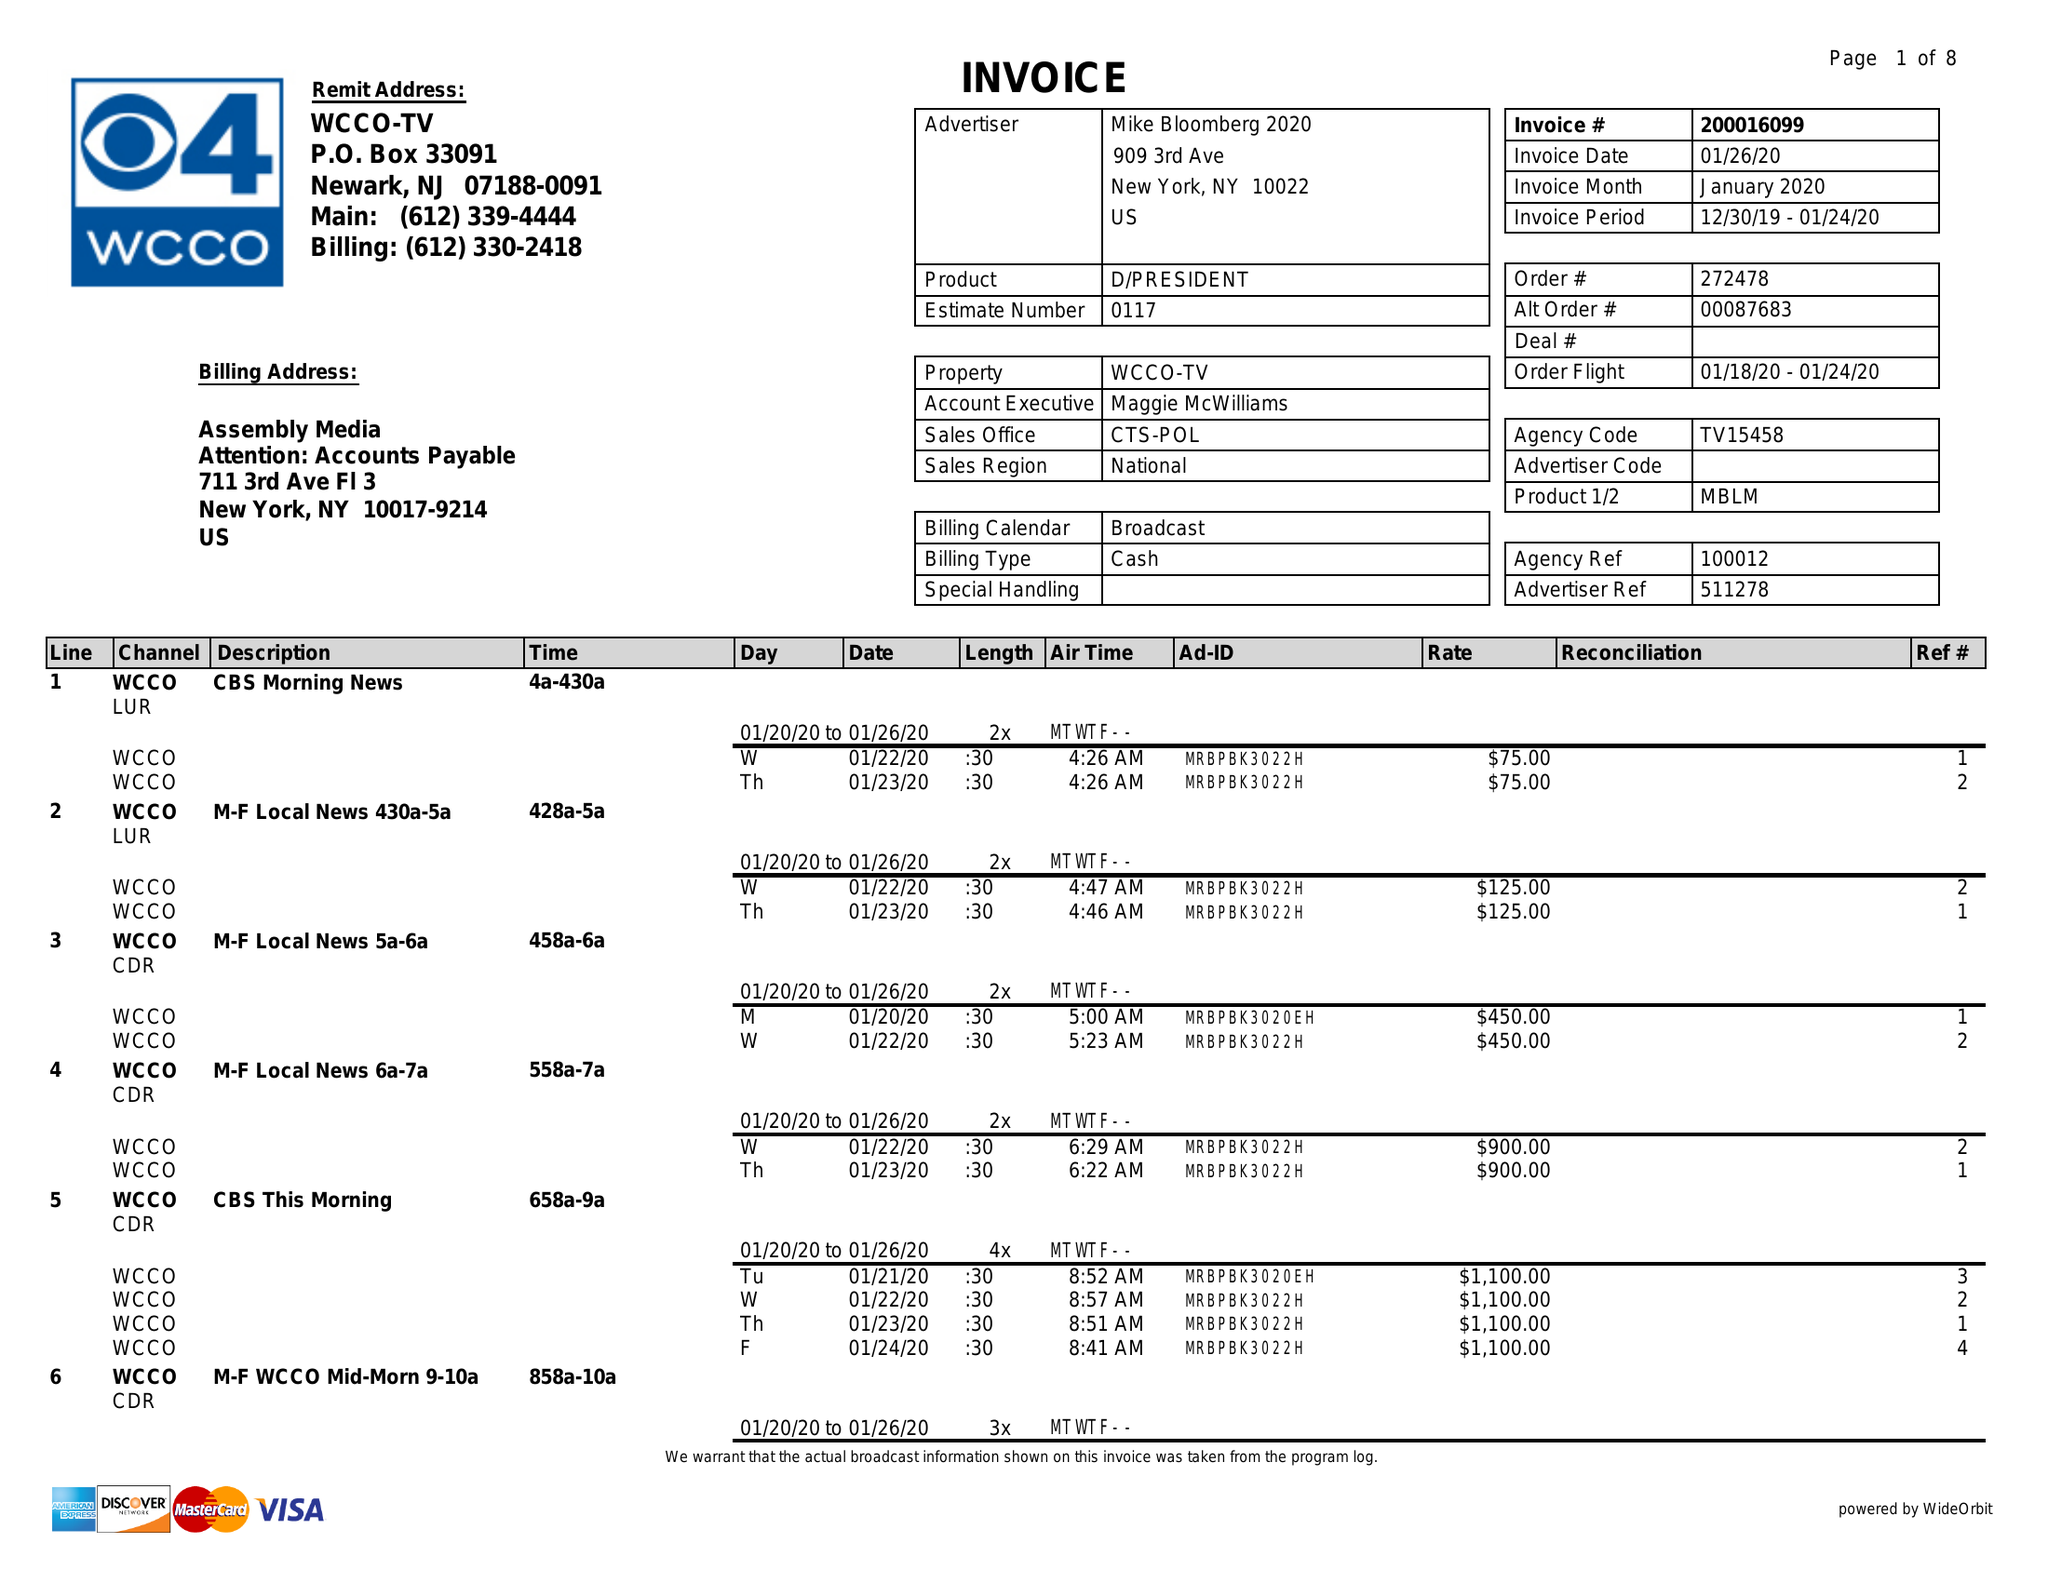What is the value for the contract_num?
Answer the question using a single word or phrase. 200016099 